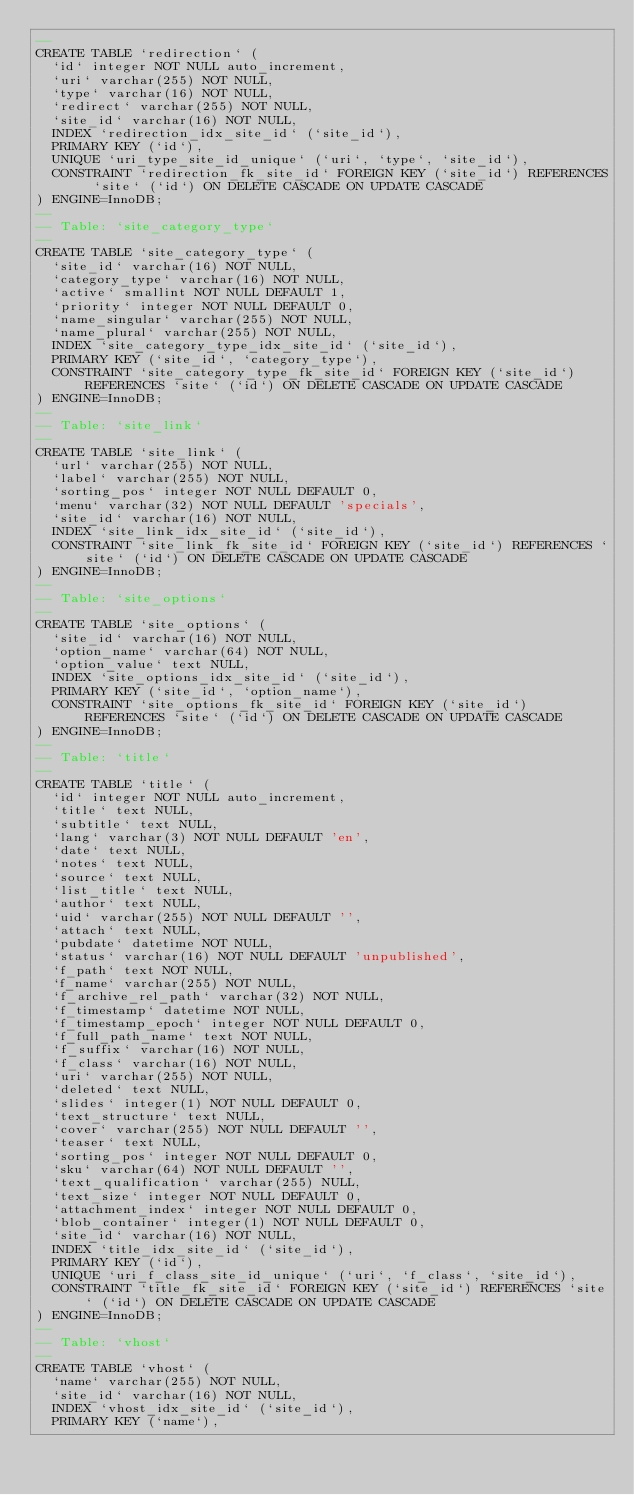Convert code to text. <code><loc_0><loc_0><loc_500><loc_500><_SQL_>--
CREATE TABLE `redirection` (
  `id` integer NOT NULL auto_increment,
  `uri` varchar(255) NOT NULL,
  `type` varchar(16) NOT NULL,
  `redirect` varchar(255) NOT NULL,
  `site_id` varchar(16) NOT NULL,
  INDEX `redirection_idx_site_id` (`site_id`),
  PRIMARY KEY (`id`),
  UNIQUE `uri_type_site_id_unique` (`uri`, `type`, `site_id`),
  CONSTRAINT `redirection_fk_site_id` FOREIGN KEY (`site_id`) REFERENCES `site` (`id`) ON DELETE CASCADE ON UPDATE CASCADE
) ENGINE=InnoDB;
--
-- Table: `site_category_type`
--
CREATE TABLE `site_category_type` (
  `site_id` varchar(16) NOT NULL,
  `category_type` varchar(16) NOT NULL,
  `active` smallint NOT NULL DEFAULT 1,
  `priority` integer NOT NULL DEFAULT 0,
  `name_singular` varchar(255) NOT NULL,
  `name_plural` varchar(255) NOT NULL,
  INDEX `site_category_type_idx_site_id` (`site_id`),
  PRIMARY KEY (`site_id`, `category_type`),
  CONSTRAINT `site_category_type_fk_site_id` FOREIGN KEY (`site_id`) REFERENCES `site` (`id`) ON DELETE CASCADE ON UPDATE CASCADE
) ENGINE=InnoDB;
--
-- Table: `site_link`
--
CREATE TABLE `site_link` (
  `url` varchar(255) NOT NULL,
  `label` varchar(255) NOT NULL,
  `sorting_pos` integer NOT NULL DEFAULT 0,
  `menu` varchar(32) NOT NULL DEFAULT 'specials',
  `site_id` varchar(16) NOT NULL,
  INDEX `site_link_idx_site_id` (`site_id`),
  CONSTRAINT `site_link_fk_site_id` FOREIGN KEY (`site_id`) REFERENCES `site` (`id`) ON DELETE CASCADE ON UPDATE CASCADE
) ENGINE=InnoDB;
--
-- Table: `site_options`
--
CREATE TABLE `site_options` (
  `site_id` varchar(16) NOT NULL,
  `option_name` varchar(64) NOT NULL,
  `option_value` text NULL,
  INDEX `site_options_idx_site_id` (`site_id`),
  PRIMARY KEY (`site_id`, `option_name`),
  CONSTRAINT `site_options_fk_site_id` FOREIGN KEY (`site_id`) REFERENCES `site` (`id`) ON DELETE CASCADE ON UPDATE CASCADE
) ENGINE=InnoDB;
--
-- Table: `title`
--
CREATE TABLE `title` (
  `id` integer NOT NULL auto_increment,
  `title` text NULL,
  `subtitle` text NULL,
  `lang` varchar(3) NOT NULL DEFAULT 'en',
  `date` text NULL,
  `notes` text NULL,
  `source` text NULL,
  `list_title` text NULL,
  `author` text NULL,
  `uid` varchar(255) NOT NULL DEFAULT '',
  `attach` text NULL,
  `pubdate` datetime NOT NULL,
  `status` varchar(16) NOT NULL DEFAULT 'unpublished',
  `f_path` text NOT NULL,
  `f_name` varchar(255) NOT NULL,
  `f_archive_rel_path` varchar(32) NOT NULL,
  `f_timestamp` datetime NOT NULL,
  `f_timestamp_epoch` integer NOT NULL DEFAULT 0,
  `f_full_path_name` text NOT NULL,
  `f_suffix` varchar(16) NOT NULL,
  `f_class` varchar(16) NOT NULL,
  `uri` varchar(255) NOT NULL,
  `deleted` text NULL,
  `slides` integer(1) NOT NULL DEFAULT 0,
  `text_structure` text NULL,
  `cover` varchar(255) NOT NULL DEFAULT '',
  `teaser` text NULL,
  `sorting_pos` integer NOT NULL DEFAULT 0,
  `sku` varchar(64) NOT NULL DEFAULT '',
  `text_qualification` varchar(255) NULL,
  `text_size` integer NOT NULL DEFAULT 0,
  `attachment_index` integer NOT NULL DEFAULT 0,
  `blob_container` integer(1) NOT NULL DEFAULT 0,
  `site_id` varchar(16) NOT NULL,
  INDEX `title_idx_site_id` (`site_id`),
  PRIMARY KEY (`id`),
  UNIQUE `uri_f_class_site_id_unique` (`uri`, `f_class`, `site_id`),
  CONSTRAINT `title_fk_site_id` FOREIGN KEY (`site_id`) REFERENCES `site` (`id`) ON DELETE CASCADE ON UPDATE CASCADE
) ENGINE=InnoDB;
--
-- Table: `vhost`
--
CREATE TABLE `vhost` (
  `name` varchar(255) NOT NULL,
  `site_id` varchar(16) NOT NULL,
  INDEX `vhost_idx_site_id` (`site_id`),
  PRIMARY KEY (`name`),</code> 